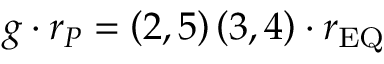Convert formula to latex. <formula><loc_0><loc_0><loc_500><loc_500>g \cdot r _ { P } = \left ( 2 , 5 \right ) \left ( 3 , 4 \right ) \cdot r _ { E Q }</formula> 